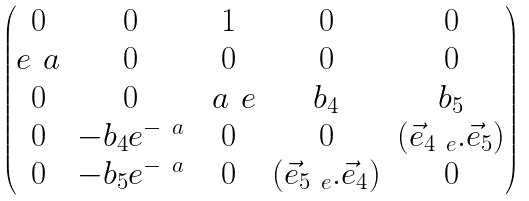<formula> <loc_0><loc_0><loc_500><loc_500>\begin{pmatrix} 0 & 0 & 1 & 0 & 0 \\ e ^ { \ } a & 0 & 0 & 0 & 0 \\ 0 & 0 & \ a _ { \ } e & b _ { 4 } & b _ { 5 } \\ 0 & - b _ { 4 } e ^ { - \ a } & 0 & 0 & ( \vec { e } _ { 4 \ e } . \vec { e } _ { 5 } ) \\ 0 & - b _ { 5 } e ^ { - \ a } & 0 & ( \vec { e } _ { 5 \ e } . \vec { e } _ { 4 } ) & 0 \end{pmatrix}</formula> 